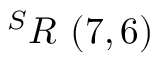Convert formula to latex. <formula><loc_0><loc_0><loc_500><loc_500>^ { S } R \ ( 7 , 6 )</formula> 